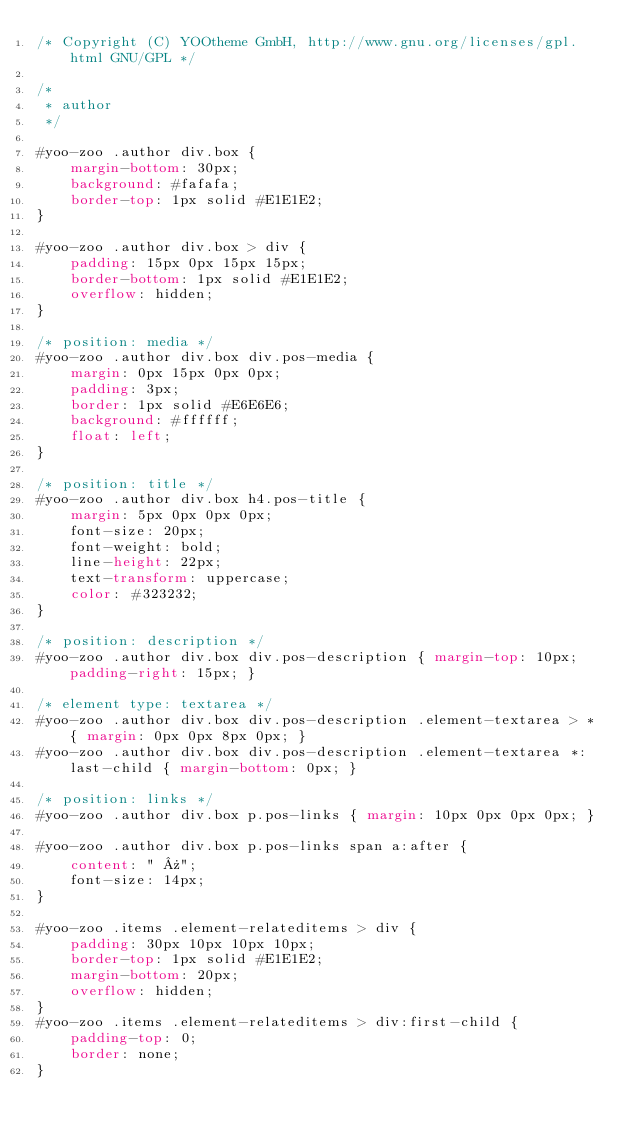<code> <loc_0><loc_0><loc_500><loc_500><_CSS_>/* Copyright (C) YOOtheme GmbH, http://www.gnu.org/licenses/gpl.html GNU/GPL */

/*
 * author
 */

#yoo-zoo .author div.box {
	margin-bottom: 30px;
	background: #fafafa;
	border-top: 1px solid #E1E1E2;
}

#yoo-zoo .author div.box > div {
	padding: 15px 0px 15px 15px;
	border-bottom: 1px solid #E1E1E2;
	overflow: hidden;
}

/* position: media */
#yoo-zoo .author div.box div.pos-media {
	margin: 0px 15px 0px 0px;
	padding: 3px;
	border: 1px solid #E6E6E6;
	background: #ffffff;
	float: left;
}

/* position: title */
#yoo-zoo .author div.box h4.pos-title {
	margin: 5px 0px 0px 0px;
	font-size: 20px;
	font-weight: bold;
	line-height: 22px;
	text-transform: uppercase;
	color: #323232;
}

/* position: description */
#yoo-zoo .author div.box div.pos-description { margin-top: 10px; padding-right: 15px; }

/* element type: textarea */
#yoo-zoo .author div.box div.pos-description .element-textarea > * { margin: 0px 0px 8px 0px; }
#yoo-zoo .author div.box div.pos-description .element-textarea *:last-child { margin-bottom: 0px; }

/* position: links */
#yoo-zoo .author div.box p.pos-links { margin: 10px 0px 0px 0px; }

#yoo-zoo .author div.box p.pos-links span a:after {
	content: " »";
	font-size: 14px;
}

#yoo-zoo .items .element-relateditems > div {
	padding: 30px 10px 10px 10px;
	border-top: 1px solid #E1E1E2;
	margin-bottom: 20px;
	overflow: hidden;
}
#yoo-zoo .items .element-relateditems > div:first-child {
	padding-top: 0;
	border: none;
}</code> 